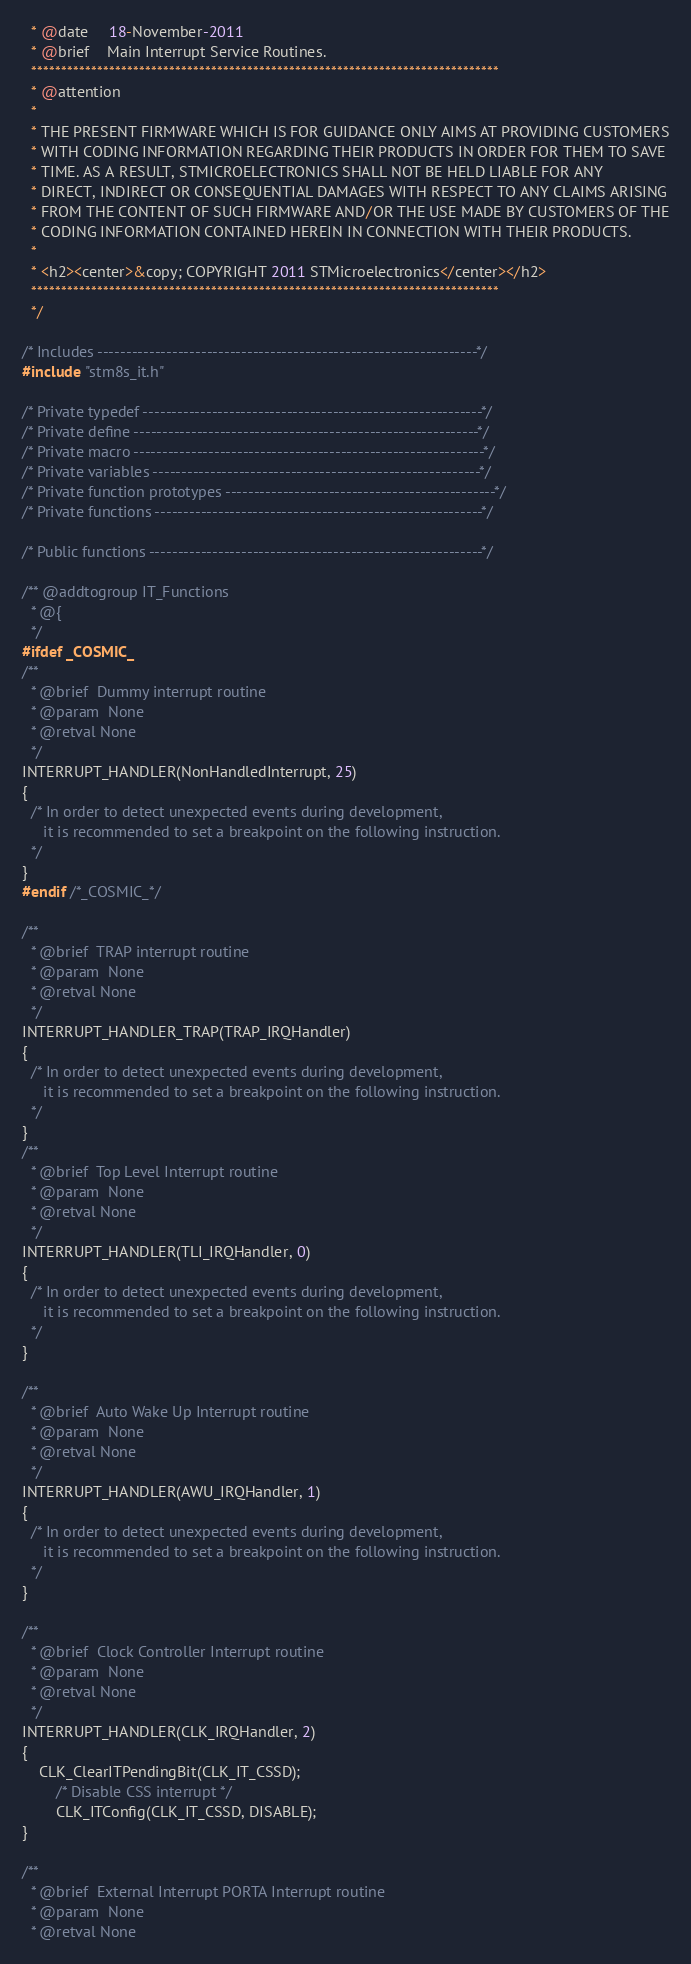<code> <loc_0><loc_0><loc_500><loc_500><_C_>  * @date     18-November-2011
  * @brief    Main Interrupt Service Routines.
  ******************************************************************************
  * @attention
  *
  * THE PRESENT FIRMWARE WHICH IS FOR GUIDANCE ONLY AIMS AT PROVIDING CUSTOMERS
  * WITH CODING INFORMATION REGARDING THEIR PRODUCTS IN ORDER FOR THEM TO SAVE
  * TIME. AS A RESULT, STMICROELECTRONICS SHALL NOT BE HELD LIABLE FOR ANY
  * DIRECT, INDIRECT OR CONSEQUENTIAL DAMAGES WITH RESPECT TO ANY CLAIMS ARISING
  * FROM THE CONTENT OF SUCH FIRMWARE AND/OR THE USE MADE BY CUSTOMERS OF THE
  * CODING INFORMATION CONTAINED HEREIN IN CONNECTION WITH THEIR PRODUCTS.
  *
  * <h2><center>&copy; COPYRIGHT 2011 STMicroelectronics</center></h2>
  ******************************************************************************
  */ 

/* Includes ------------------------------------------------------------------*/
#include "stm8s_it.h"

/* Private typedef -----------------------------------------------------------*/
/* Private define ------------------------------------------------------------*/
/* Private macro -------------------------------------------------------------*/
/* Private variables ---------------------------------------------------------*/
/* Private function prototypes -----------------------------------------------*/
/* Private functions ---------------------------------------------------------*/

/* Public functions ----------------------------------------------------------*/

/** @addtogroup IT_Functions
  * @{
  */
#ifdef _COSMIC_
/**
  * @brief  Dummy interrupt routine
  * @param  None
  * @retval None
  */
INTERRUPT_HANDLER(NonHandledInterrupt, 25)
{
  /* In order to detect unexpected events during development,
     it is recommended to set a breakpoint on the following instruction.
  */
}
#endif /*_COSMIC_*/

/**
  * @brief  TRAP interrupt routine
  * @param  None
  * @retval None
  */
INTERRUPT_HANDLER_TRAP(TRAP_IRQHandler)
{
  /* In order to detect unexpected events during development,
     it is recommended to set a breakpoint on the following instruction.
  */
}
/**
  * @brief  Top Level Interrupt routine
  * @param  None
  * @retval None
  */
INTERRUPT_HANDLER(TLI_IRQHandler, 0)
{
  /* In order to detect unexpected events during development,
     it is recommended to set a breakpoint on the following instruction.
  */
}

/**
  * @brief  Auto Wake Up Interrupt routine
  * @param  None
  * @retval None
  */
INTERRUPT_HANDLER(AWU_IRQHandler, 1)
{
  /* In order to detect unexpected events during development,
     it is recommended to set a breakpoint on the following instruction.
  */
}

/**
  * @brief  Clock Controller Interrupt routine
  * @param  None
  * @retval None
  */
INTERRUPT_HANDLER(CLK_IRQHandler, 2)
{
    CLK_ClearITPendingBit(CLK_IT_CSSD);
		/* Disable CSS interrupt */
		CLK_ITConfig(CLK_IT_CSSD, DISABLE);
}

/**
  * @brief  External Interrupt PORTA Interrupt routine
  * @param  None
  * @retval None</code> 